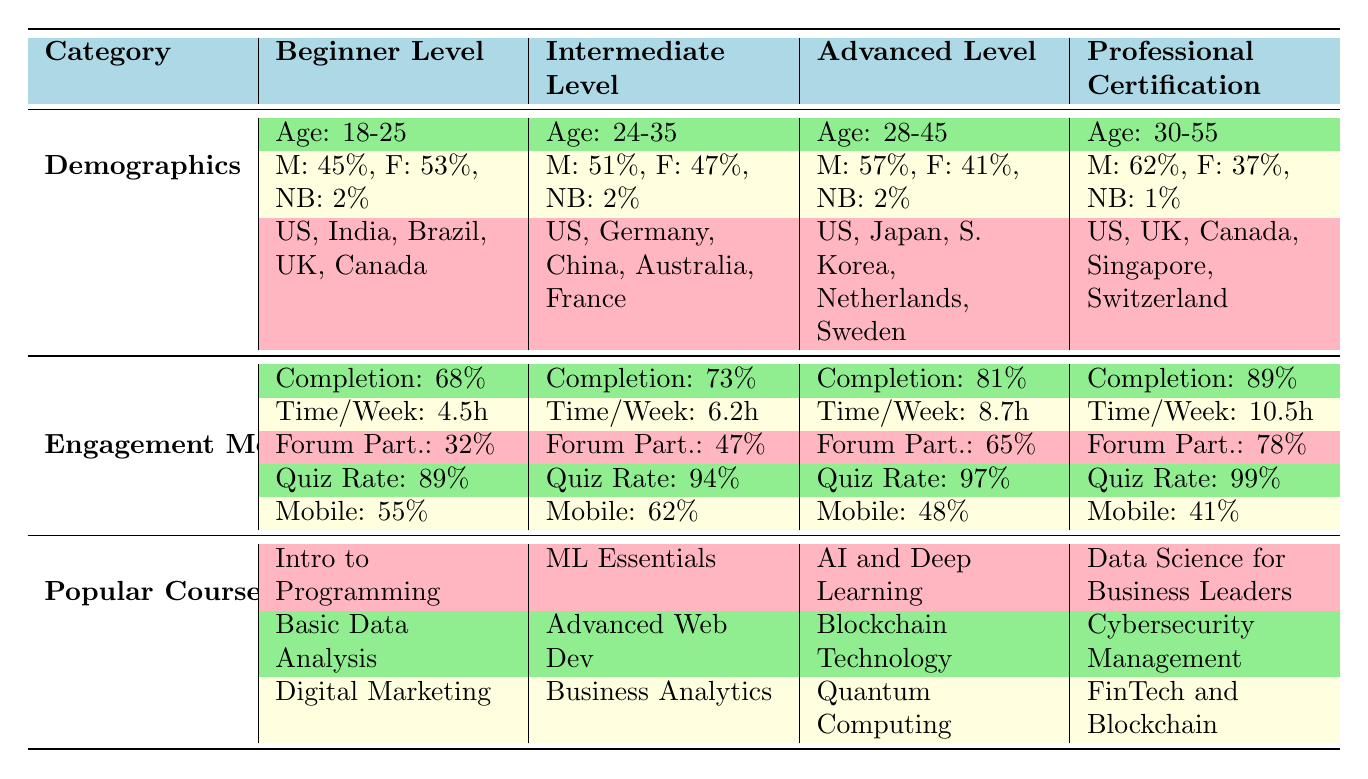What is the average course completion rate for the Professional Certification level? The table shows that the average course completion rate for the Professional Certification level is 89%.
Answer: 89% What is the age range of students in the Beginner Level courses? According to the table, the age range for students in the Beginner Level courses is 18-25 years old.
Answer: 18-25 Which engagement metric shows the highest value for the Advanced Level? The table lists the quiz attempt rate for the Advanced Level at 97%, which is the highest value compared to other metrics for that level.
Answer: 97% How does the average time spent per week differ between the Intermediate and the Professional Certification levels? The average time spent per week for the Intermediate level is 6.2 hours, and for the Professional Certification level, it is 10.5 hours. The difference is 10.5 - 6.2 = 4.3 hours.
Answer: 4.3 hours Is it true that the percentage of female students is higher in the Beginner Level compared to the Professional Certification level? The Beginner Level has 53% female students, while the Professional Certification level has 37%. Therefore, the statement is true.
Answer: Yes Which level has the lowest percentage of Mobile App usage? The table indicates that the Mobile App usage percentage is lowest for the Professional Certification level at 41%.
Answer: 41% What is the sum of the average course completion rates for all levels? Adding the completion rates: 68% + 73% + 81% + 89% equals 311%.
Answer: 311% Which level has the highest forum participation rate? The Advanced Level has the highest forum participation rate at 65%, according to the table.
Answer: 65% If you compare the Average Time Spent per Week between Beginner and Advanced levels, how much more time do Advanced level students spend? The Advanced level students spend 8.7 hours and Beginner level students spend 4.5 hours. The difference is 8.7 - 4.5 = 4.2 hours more for Advanced level students.
Answer: 4.2 hours What is the gender distribution of students in the Professional Certification level? The table shows that the gender distribution is 62% male, 37% female, and 1% non-binary for the Professional Certification level.
Answer: M: 62%, F: 37%, NB: 1% 